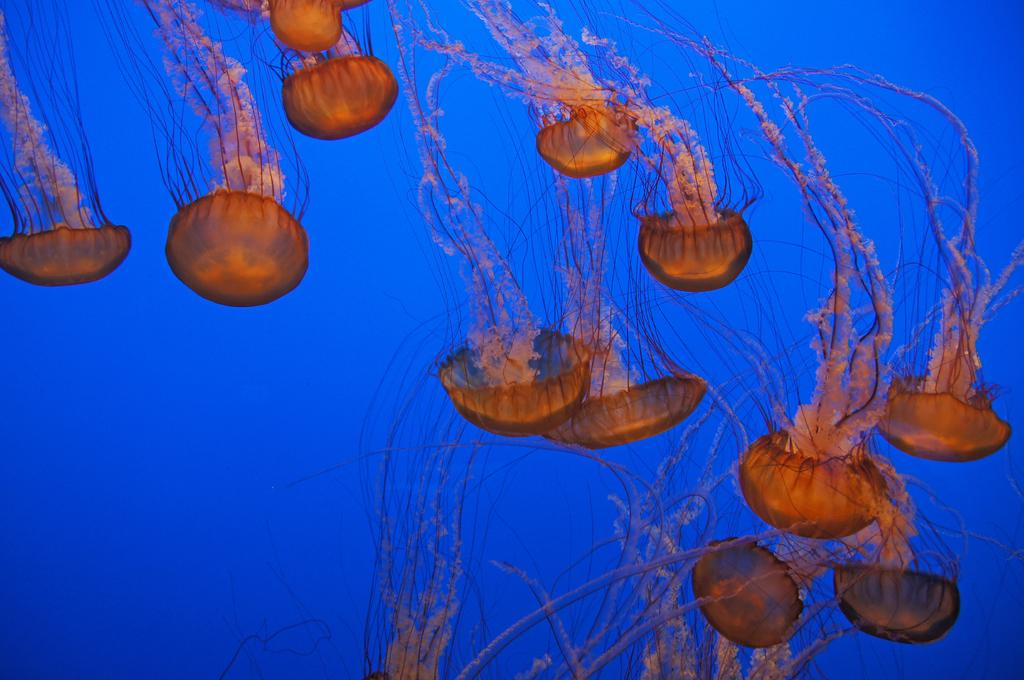What type of sea creatures are in the image? There are jelly fishes in the image. What color is the background of the image? The background color is blue. How many brothers are visible in the image? There are no brothers present in the image; it features jelly fishes in a blue background. What type of cord is used to hang the jelly fishes in the image? There is no cord visible in the image, as the jelly fishes are likely in water or a similar environment. 